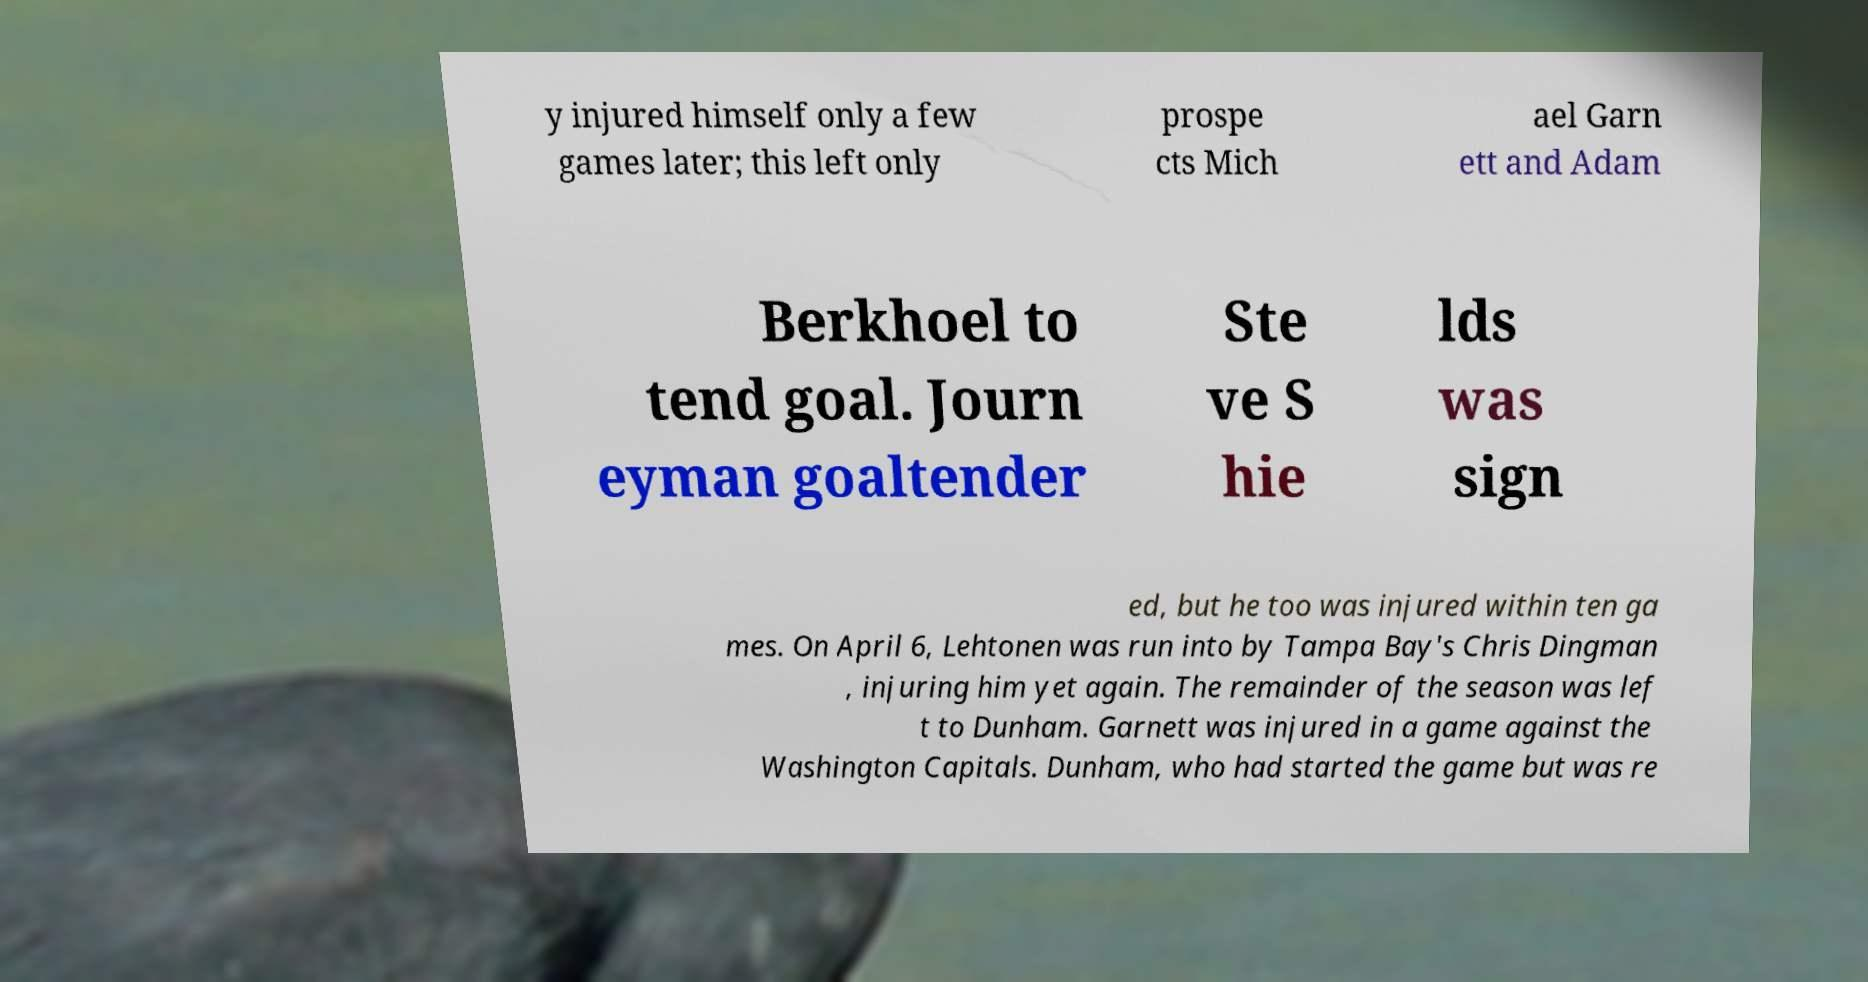Please read and relay the text visible in this image. What does it say? y injured himself only a few games later; this left only prospe cts Mich ael Garn ett and Adam Berkhoel to tend goal. Journ eyman goaltender Ste ve S hie lds was sign ed, but he too was injured within ten ga mes. On April 6, Lehtonen was run into by Tampa Bay's Chris Dingman , injuring him yet again. The remainder of the season was lef t to Dunham. Garnett was injured in a game against the Washington Capitals. Dunham, who had started the game but was re 